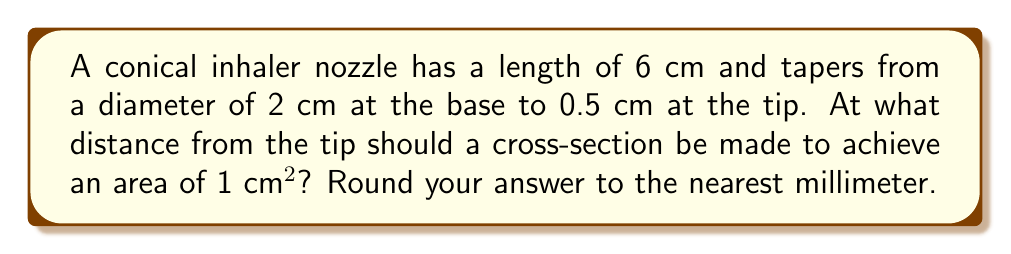What is the answer to this math problem? Let's approach this step-by-step:

1) First, we need to understand that the cross-section of a cone is a circle. The area of this circle changes as we move along the length of the cone.

2) Let's define some variables:
   $r$ = radius at the cross-section
   $x$ = distance from the tip to the cross-section
   $R$ = radius at the base (1 cm)
   $r_t$ = radius at the tip (0.25 cm)
   $L$ = length of the cone (6 cm)

3) The area of the cross-section is given by $A = \pi r^2$. We're told this area should be 1 cm², so:

   $$\pi r^2 = 1$$
   $$r^2 = \frac{1}{\pi}$$
   $$r = \frac{1}{\sqrt{\pi}} \approx 0.5642 \text{ cm}$$

4) Now, we need to find where along the cone this radius occurs. We can use similar triangles:

   $$\frac{R - r_t}{L} = \frac{r - r_t}{x}$$

5) Substituting the known values:

   $$\frac{1 - 0.25}{6} = \frac{0.5642 - 0.25}{x}$$

6) Solving for $x$:

   $$\frac{0.75}{6} = \frac{0.3142}{x}$$
   $$x = \frac{0.3142 \times 6}{0.75} \approx 2.5136 \text{ cm}$$

7) Rounding to the nearest millimeter:

   $x \approx 2.5 \text{ cm}$

[asy]
import geometry;

unitsize(1cm);

pair A = (0,0), B = (6,1), C = (6,-1), D = (2.5, 0.5642), E = (2.5, -0.5642);

draw(A--B--C--cycle);
draw(D--E);

label("6 cm", (3,-1.2), S);
label("2 cm", (6,0), E);
label("0.5 cm", (0,0), W);
label("2.5 cm", (2.5,-1.2), S);
label("1 cm²", (2.5,0), E);

dot("A", A, W);
dot("B", B, NE);
dot("C", C, SE);
[/asy]

This diagram illustrates the conical inhaler nozzle and the cross-section where the area is 1 cm².
Answer: The cross-section should be made at approximately 2.5 cm from the tip of the conical inhaler nozzle to achieve an area of 1 cm². 